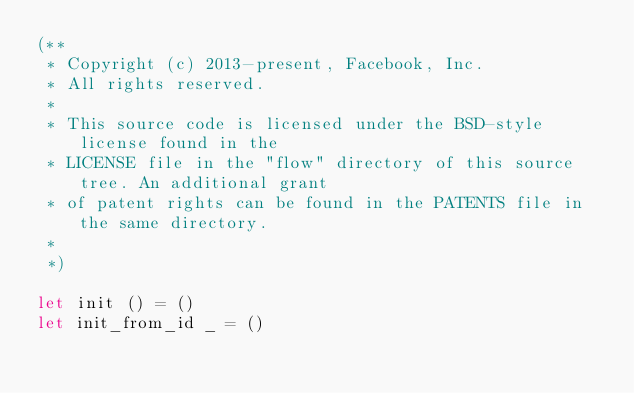Convert code to text. <code><loc_0><loc_0><loc_500><loc_500><_OCaml_>(**
 * Copyright (c) 2013-present, Facebook, Inc.
 * All rights reserved.
 *
 * This source code is licensed under the BSD-style license found in the
 * LICENSE file in the "flow" directory of this source tree. An additional grant
 * of patent rights can be found in the PATENTS file in the same directory.
 *
 *)

let init () = ()
let init_from_id _ = ()</code> 